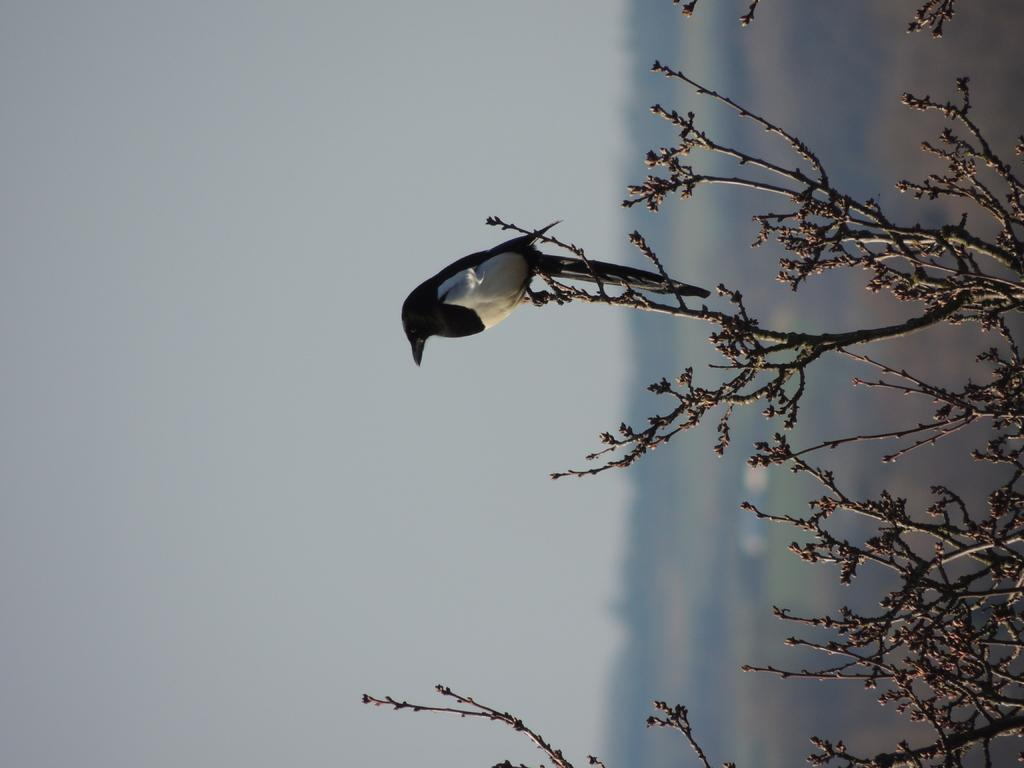What type of animal is in the image? There is a bird in the image. Where is the bird located? The bird is sitting on the stem of a plant. What can be seen in the background of the image? There are trees in the background of the image. What is the condition of the sky in the image? The sky is clear in the image. What color is the crayon that the bird is using to draw in the image? There is no crayon or drawing activity present in the image; it features a bird sitting on a plant stem. 